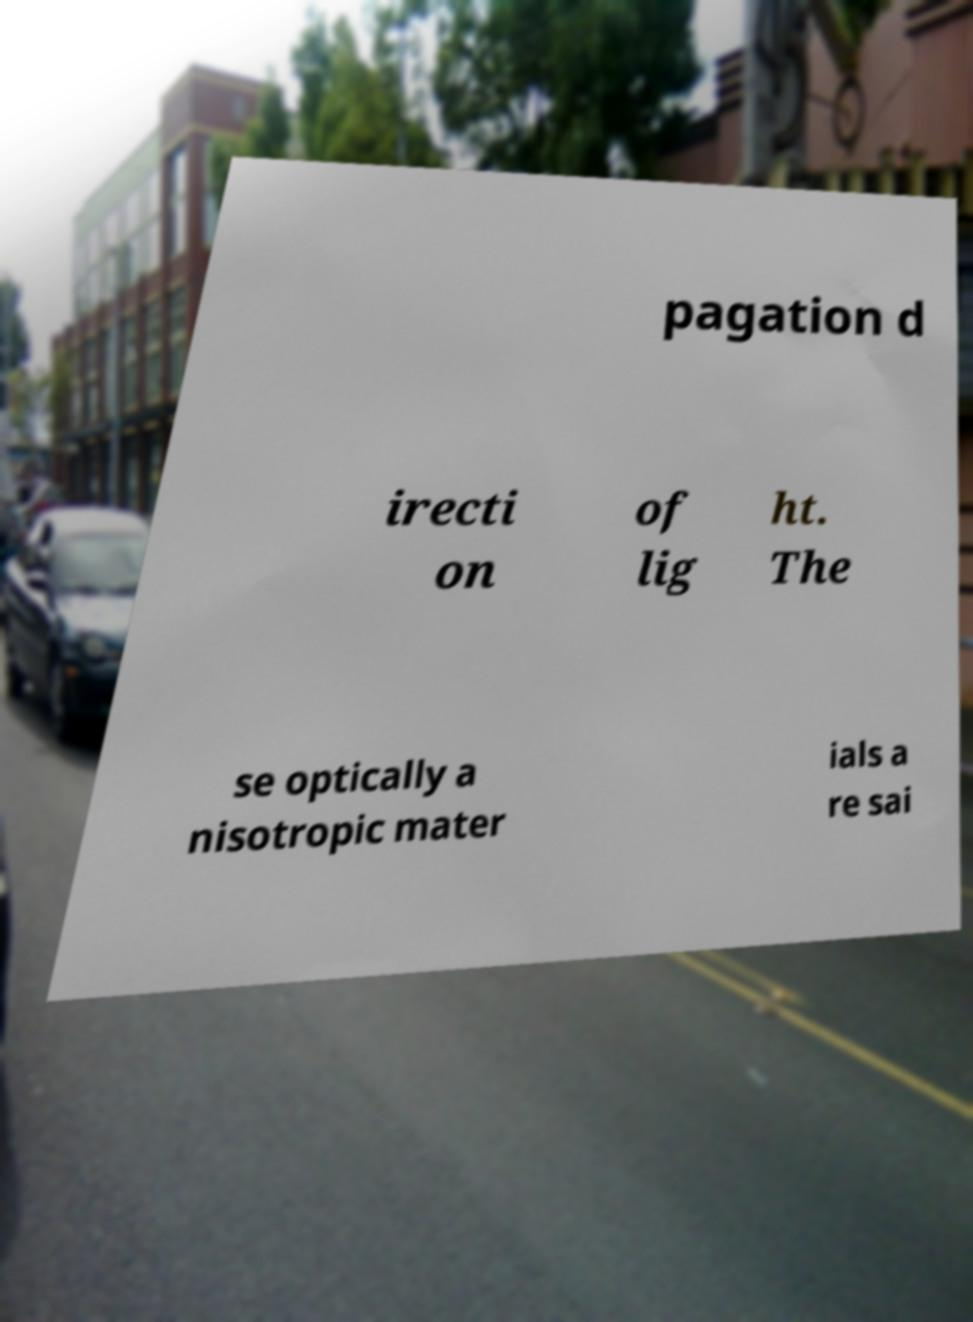For documentation purposes, I need the text within this image transcribed. Could you provide that? pagation d irecti on of lig ht. The se optically a nisotropic mater ials a re sai 